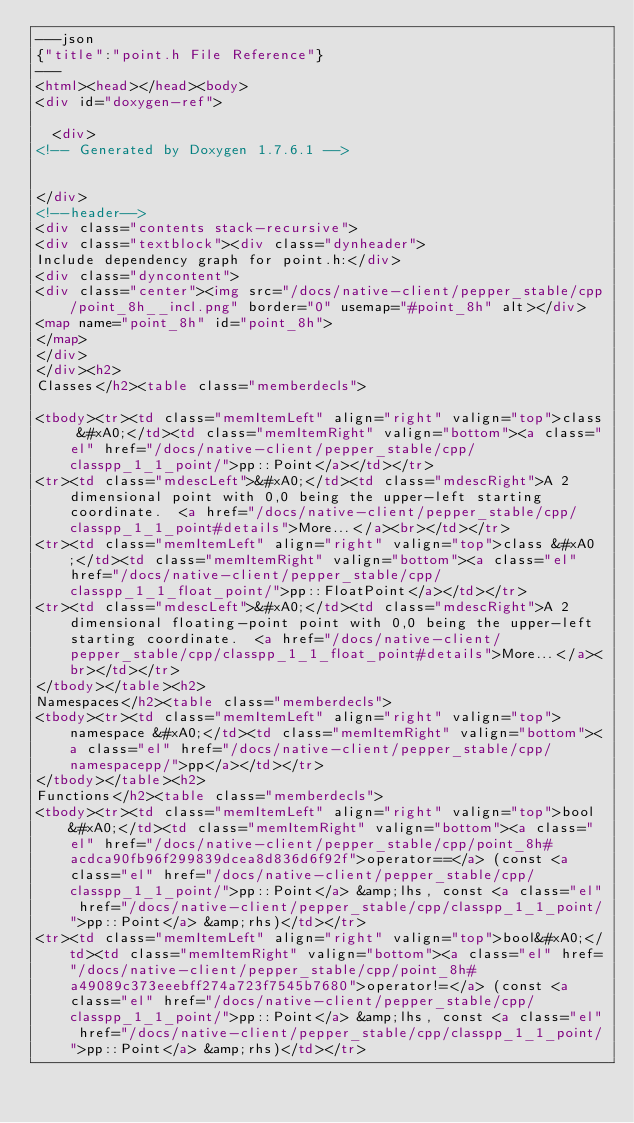<code> <loc_0><loc_0><loc_500><loc_500><_HTML_>---json
{"title":"point.h File Reference"}
---
<html><head></head><body>
<div id="doxygen-ref">

  <div>
<!-- Generated by Doxygen 1.7.6.1 -->


</div>
<!--header-->
<div class="contents stack-recursive">
<div class="textblock"><div class="dynheader">
Include dependency graph for point.h:</div>
<div class="dyncontent">
<div class="center"><img src="/docs/native-client/pepper_stable/cpp/point_8h__incl.png" border="0" usemap="#point_8h" alt></div>
<map name="point_8h" id="point_8h">
</map>
</div>
</div><h2>
Classes</h2><table class="memberdecls">

<tbody><tr><td class="memItemLeft" align="right" valign="top">class &#xA0;</td><td class="memItemRight" valign="bottom"><a class="el" href="/docs/native-client/pepper_stable/cpp/classpp_1_1_point/">pp::Point</a></td></tr>
<tr><td class="mdescLeft">&#xA0;</td><td class="mdescRight">A 2 dimensional point with 0,0 being the upper-left starting coordinate.  <a href="/docs/native-client/pepper_stable/cpp/classpp_1_1_point#details">More...</a><br></td></tr>
<tr><td class="memItemLeft" align="right" valign="top">class &#xA0;</td><td class="memItemRight" valign="bottom"><a class="el" href="/docs/native-client/pepper_stable/cpp/classpp_1_1_float_point/">pp::FloatPoint</a></td></tr>
<tr><td class="mdescLeft">&#xA0;</td><td class="mdescRight">A 2 dimensional floating-point point with 0,0 being the upper-left starting coordinate.  <a href="/docs/native-client/pepper_stable/cpp/classpp_1_1_float_point#details">More...</a><br></td></tr>
</tbody></table><h2>
Namespaces</h2><table class="memberdecls">
<tbody><tr><td class="memItemLeft" align="right" valign="top">namespace &#xA0;</td><td class="memItemRight" valign="bottom"><a class="el" href="/docs/native-client/pepper_stable/cpp/namespacepp/">pp</a></td></tr>
</tbody></table><h2>
Functions</h2><table class="memberdecls">
<tbody><tr><td class="memItemLeft" align="right" valign="top">bool&#xA0;</td><td class="memItemRight" valign="bottom"><a class="el" href="/docs/native-client/pepper_stable/cpp/point_8h#acdca90fb96f299839dcea8d836d6f92f">operator==</a> (const <a class="el" href="/docs/native-client/pepper_stable/cpp/classpp_1_1_point/">pp::Point</a> &amp;lhs, const <a class="el" href="/docs/native-client/pepper_stable/cpp/classpp_1_1_point/">pp::Point</a> &amp;rhs)</td></tr>
<tr><td class="memItemLeft" align="right" valign="top">bool&#xA0;</td><td class="memItemRight" valign="bottom"><a class="el" href="/docs/native-client/pepper_stable/cpp/point_8h#a49089c373eeebff274a723f7545b7680">operator!=</a> (const <a class="el" href="/docs/native-client/pepper_stable/cpp/classpp_1_1_point/">pp::Point</a> &amp;lhs, const <a class="el" href="/docs/native-client/pepper_stable/cpp/classpp_1_1_point/">pp::Point</a> &amp;rhs)</td></tr></code> 